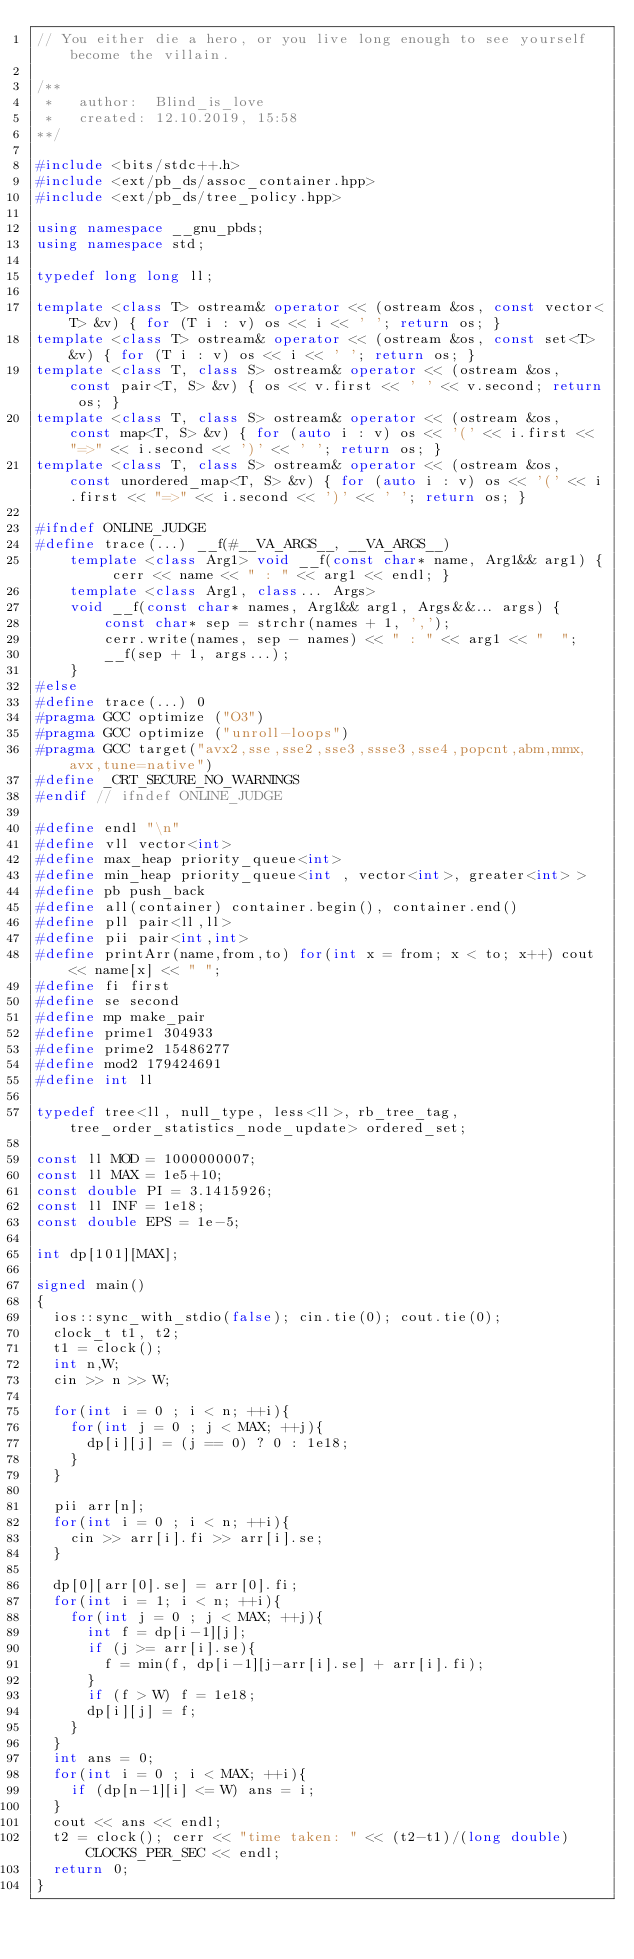<code> <loc_0><loc_0><loc_500><loc_500><_C++_>// You either die a hero, or you live long enough to see yourself become the villain.

/**
 *   author:  Blind_is_love
 *   created: 12.10.2019, 15:58
**/

#include <bits/stdc++.h>
#include <ext/pb_ds/assoc_container.hpp>
#include <ext/pb_ds/tree_policy.hpp>

using namespace __gnu_pbds;
using namespace std;

typedef long long ll;

template <class T> ostream& operator << (ostream &os, const vector<T> &v) { for (T i : v) os << i << ' '; return os; }
template <class T> ostream& operator << (ostream &os, const set<T> &v) { for (T i : v) os << i << ' '; return os; }
template <class T, class S> ostream& operator << (ostream &os, const pair<T, S> &v) { os << v.first << ' ' << v.second; return os; }
template <class T, class S> ostream& operator << (ostream &os, const map<T, S> &v) { for (auto i : v) os << '(' << i.first << "=>" << i.second << ')' << ' '; return os; }
template <class T, class S> ostream& operator << (ostream &os, const unordered_map<T, S> &v) { for (auto i : v) os << '(' << i.first << "=>" << i.second << ')' << ' '; return os; }
 
#ifndef ONLINE_JUDGE
#define trace(...) __f(#__VA_ARGS__, __VA_ARGS__)
    template <class Arg1> void __f(const char* name, Arg1&& arg1) { cerr << name << " : " << arg1 << endl; }
    template <class Arg1, class... Args>
    void __f(const char* names, Arg1&& arg1, Args&&... args) {
        const char* sep = strchr(names + 1, ',');
        cerr.write(names, sep - names) << " : " << arg1 << "  ";
        __f(sep + 1, args...);
    }
#else
#define trace(...) 0
#pragma GCC optimize ("O3")
#pragma GCC optimize ("unroll-loops")
#pragma GCC target("avx2,sse,sse2,sse3,ssse3,sse4,popcnt,abm,mmx,avx,tune=native")
#define _CRT_SECURE_NO_WARNINGS
#endif // ifndef ONLINE_JUDGE

#define endl "\n"
#define vll vector<int>
#define max_heap priority_queue<int>
#define min_heap priority_queue<int , vector<int>, greater<int> >
#define pb push_back
#define all(container) container.begin(), container.end()
#define pll pair<ll,ll>
#define pii pair<int,int>
#define printArr(name,from,to) for(int x = from; x < to; x++) cout << name[x] << " ";
#define fi first
#define se second
#define mp make_pair
#define prime1 304933
#define prime2 15486277 
#define mod2 179424691
#define int ll

typedef tree<ll, null_type, less<ll>, rb_tree_tag,tree_order_statistics_node_update> ordered_set; 

const ll MOD = 1000000007;
const ll MAX = 1e5+10;
const double PI = 3.1415926;
const ll INF = 1e18;
const double EPS = 1e-5;

int dp[101][MAX];

signed main()
{
	ios::sync_with_stdio(false); cin.tie(0); cout.tie(0);
	clock_t t1, t2;
	t1 = clock();
	int n,W;
	cin >> n >> W;
	
	for(int i = 0 ; i < n; ++i){
		for(int j = 0 ; j < MAX; ++j){
			dp[i][j] = (j == 0) ? 0 : 1e18;
		}
	}

	pii arr[n];
	for(int i = 0 ; i < n; ++i){
		cin >> arr[i].fi >> arr[i].se;
	}

	dp[0][arr[0].se] = arr[0].fi;
	for(int i = 1; i < n; ++i){
		for(int j = 0 ; j < MAX; ++j){
			int f = dp[i-1][j];
			if (j >= arr[i].se){
				f = min(f, dp[i-1][j-arr[i].se] + arr[i].fi);
			}
			if (f > W) f = 1e18;
			dp[i][j] = f;
		}
	}
	int ans = 0;
	for(int i = 0 ; i < MAX; ++i){
		if (dp[n-1][i] <= W) ans = i;
	}
	cout << ans << endl;
	t2 = clock(); cerr << "time taken: " << (t2-t1)/(long double)CLOCKS_PER_SEC << endl;
	return 0;
}
</code> 